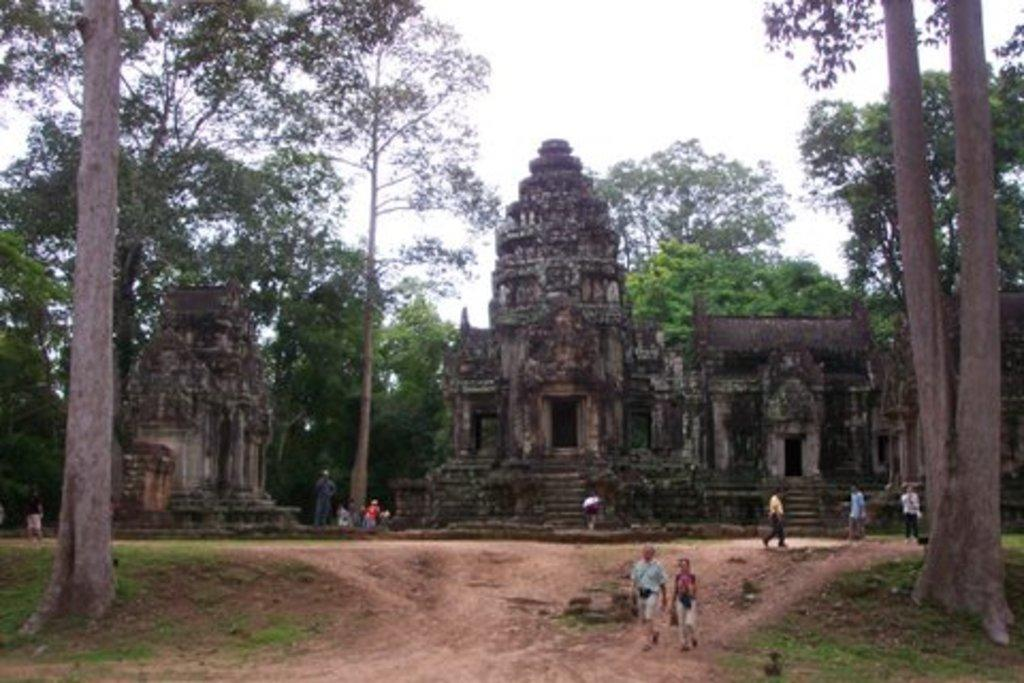What type of structure is present in the image? There is a temple in the image. What is the surrounding environment of the temple? The temple is surrounded by trees. Are there any people in the image? Yes, there are tourists in the image. What are the tourists doing in the image? The tourists are walking on the ground. Can you see any geese or a pail in the image? No, there are no geese or pail present in the image. 